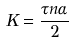<formula> <loc_0><loc_0><loc_500><loc_500>K = \frac { \tau n \alpha } { 2 }</formula> 